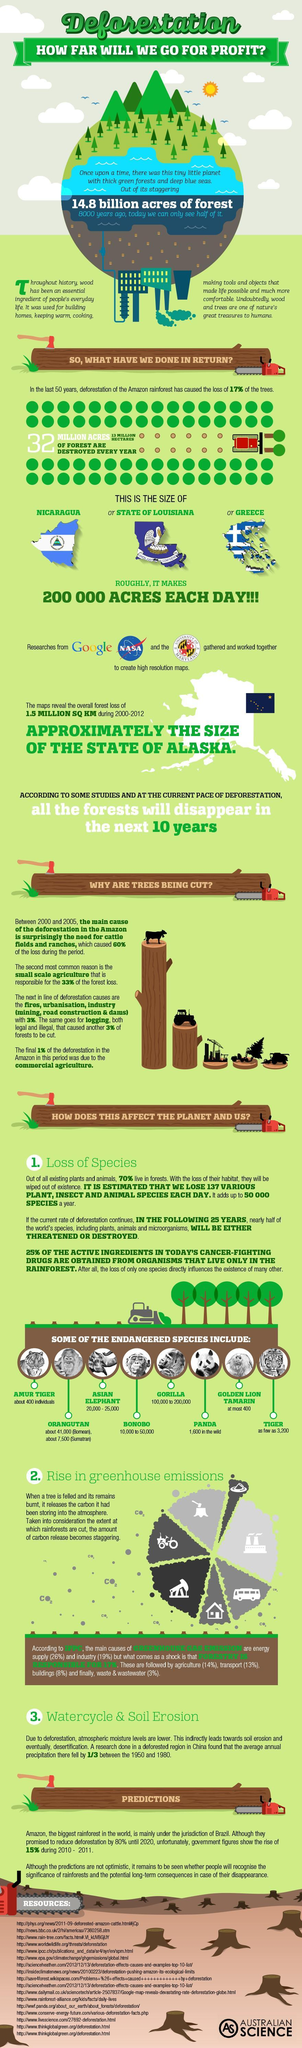what is the count of asian elephant
Answer the question with a short phrase. 20,000 - 25,000 what is the percentage of greenhouse gas emission due to agriculture, transport and wastewater 30 what is the count of golden lion tamarin 400 which agency is working with google NASA How many acres of forest are destroyed every year 32 million which endangered species has the highest count gorilla how much percentage of forest loss has been due to need for cattle filed and ranches and small scale agriculture 93 